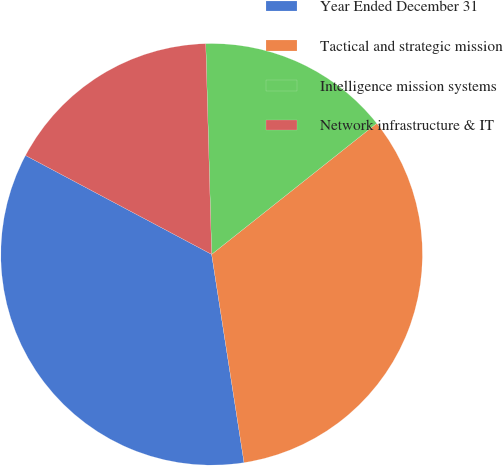Convert chart to OTSL. <chart><loc_0><loc_0><loc_500><loc_500><pie_chart><fcel>Year Ended December 31<fcel>Tactical and strategic mission<fcel>Intelligence mission systems<fcel>Network infrastructure & IT<nl><fcel>35.23%<fcel>33.22%<fcel>14.77%<fcel>16.78%<nl></chart> 